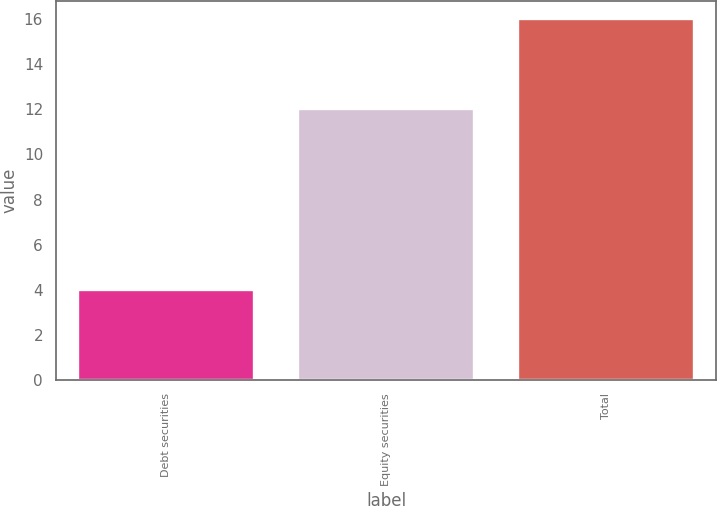Convert chart. <chart><loc_0><loc_0><loc_500><loc_500><bar_chart><fcel>Debt securities<fcel>Equity securities<fcel>Total<nl><fcel>4<fcel>12<fcel>16<nl></chart> 